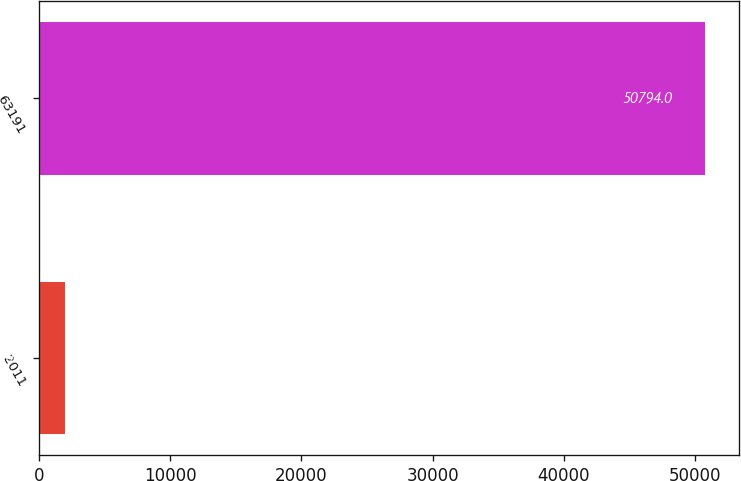Convert chart to OTSL. <chart><loc_0><loc_0><loc_500><loc_500><bar_chart><fcel>2011<fcel>63191<nl><fcel>2008<fcel>50794<nl></chart> 